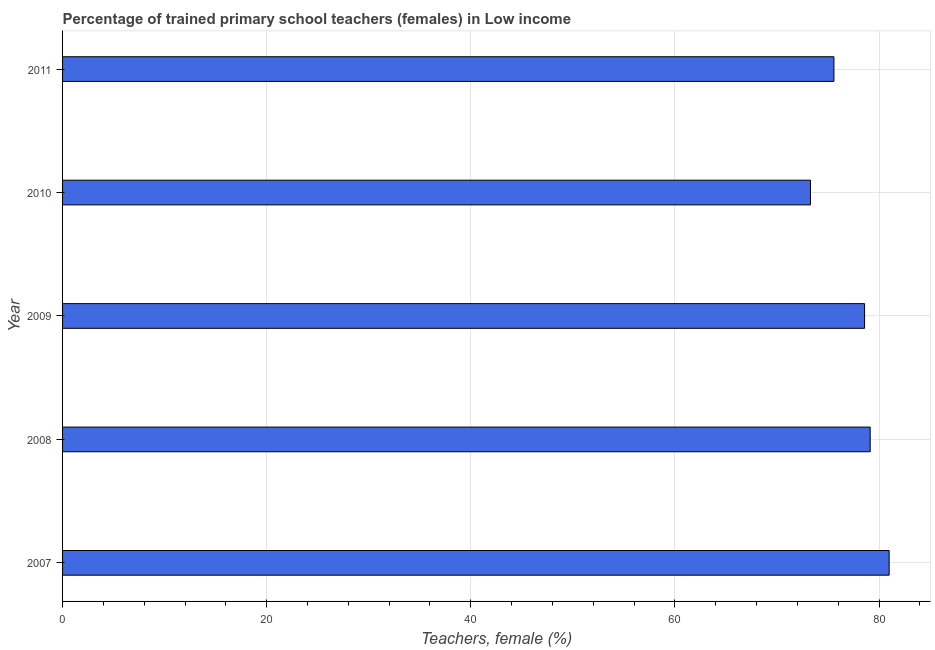Does the graph contain any zero values?
Offer a terse response. No. What is the title of the graph?
Offer a very short reply. Percentage of trained primary school teachers (females) in Low income. What is the label or title of the X-axis?
Your answer should be compact. Teachers, female (%). What is the percentage of trained female teachers in 2007?
Keep it short and to the point. 80.99. Across all years, what is the maximum percentage of trained female teachers?
Make the answer very short. 80.99. Across all years, what is the minimum percentage of trained female teachers?
Keep it short and to the point. 73.29. What is the sum of the percentage of trained female teachers?
Ensure brevity in your answer.  387.58. What is the difference between the percentage of trained female teachers in 2007 and 2011?
Provide a succinct answer. 5.41. What is the average percentage of trained female teachers per year?
Offer a very short reply. 77.52. What is the median percentage of trained female teachers?
Make the answer very short. 78.58. In how many years, is the percentage of trained female teachers greater than 48 %?
Offer a terse response. 5. Do a majority of the years between 2009 and 2011 (inclusive) have percentage of trained female teachers greater than 4 %?
Give a very brief answer. Yes. What is the difference between the highest and the second highest percentage of trained female teachers?
Offer a very short reply. 1.86. What is the difference between the highest and the lowest percentage of trained female teachers?
Offer a very short reply. 7.71. Are all the bars in the graph horizontal?
Your response must be concise. Yes. How many years are there in the graph?
Offer a terse response. 5. Are the values on the major ticks of X-axis written in scientific E-notation?
Your response must be concise. No. What is the Teachers, female (%) in 2007?
Offer a terse response. 80.99. What is the Teachers, female (%) of 2008?
Your answer should be compact. 79.13. What is the Teachers, female (%) of 2009?
Provide a short and direct response. 78.58. What is the Teachers, female (%) in 2010?
Your response must be concise. 73.29. What is the Teachers, female (%) in 2011?
Give a very brief answer. 75.58. What is the difference between the Teachers, female (%) in 2007 and 2008?
Your response must be concise. 1.86. What is the difference between the Teachers, female (%) in 2007 and 2009?
Provide a succinct answer. 2.41. What is the difference between the Teachers, female (%) in 2007 and 2010?
Give a very brief answer. 7.71. What is the difference between the Teachers, female (%) in 2007 and 2011?
Keep it short and to the point. 5.41. What is the difference between the Teachers, female (%) in 2008 and 2009?
Your answer should be compact. 0.55. What is the difference between the Teachers, female (%) in 2008 and 2010?
Provide a short and direct response. 5.85. What is the difference between the Teachers, female (%) in 2008 and 2011?
Make the answer very short. 3.55. What is the difference between the Teachers, female (%) in 2009 and 2010?
Provide a short and direct response. 5.3. What is the difference between the Teachers, female (%) in 2009 and 2011?
Ensure brevity in your answer.  3. What is the difference between the Teachers, female (%) in 2010 and 2011?
Provide a succinct answer. -2.3. What is the ratio of the Teachers, female (%) in 2007 to that in 2008?
Your answer should be very brief. 1.02. What is the ratio of the Teachers, female (%) in 2007 to that in 2009?
Your answer should be compact. 1.03. What is the ratio of the Teachers, female (%) in 2007 to that in 2010?
Keep it short and to the point. 1.1. What is the ratio of the Teachers, female (%) in 2007 to that in 2011?
Offer a terse response. 1.07. What is the ratio of the Teachers, female (%) in 2008 to that in 2010?
Provide a succinct answer. 1.08. What is the ratio of the Teachers, female (%) in 2008 to that in 2011?
Your answer should be compact. 1.05. What is the ratio of the Teachers, female (%) in 2009 to that in 2010?
Make the answer very short. 1.07. What is the ratio of the Teachers, female (%) in 2009 to that in 2011?
Your response must be concise. 1.04. 